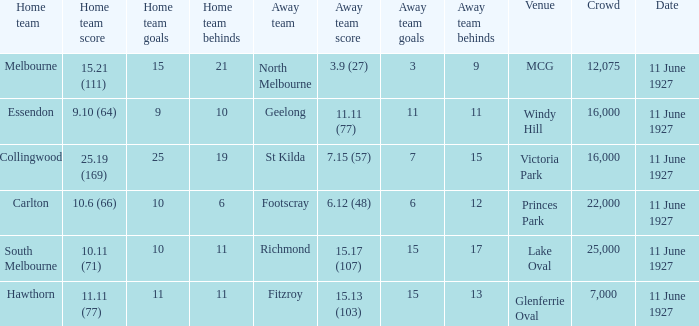What was the score for the home team of Essendon? 9.10 (64). 